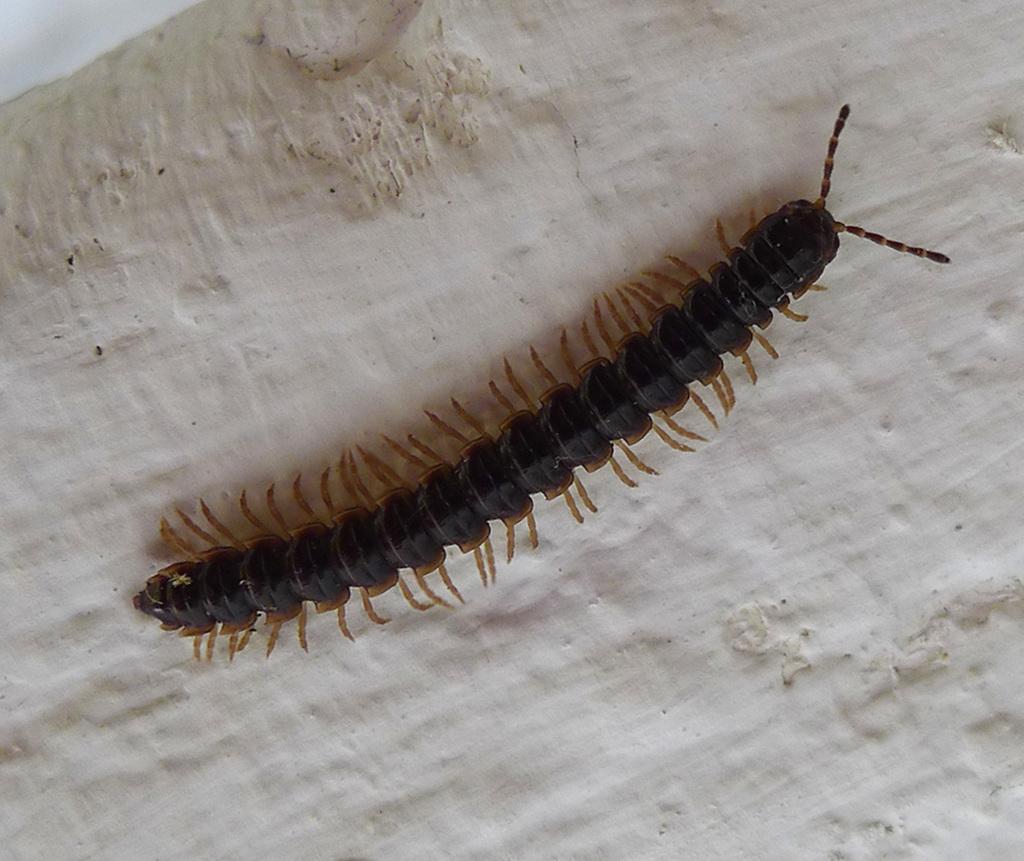How would you summarize this image in a sentence or two? In this image I can see an insect which is in black and brown color. It is on the cream color surface. 